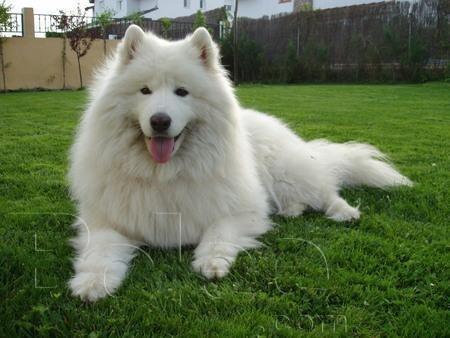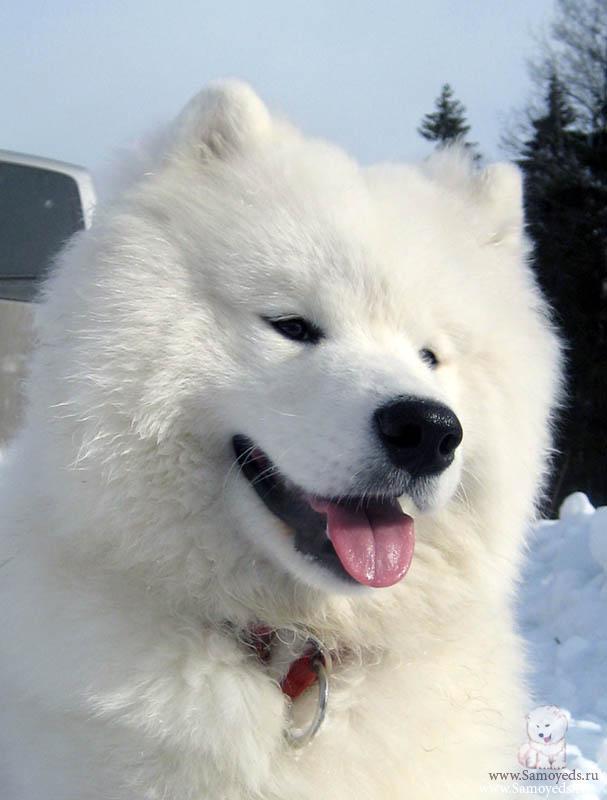The first image is the image on the left, the second image is the image on the right. Analyze the images presented: Is the assertion "One of the dogs is lying down on grass." valid? Answer yes or no. Yes. 